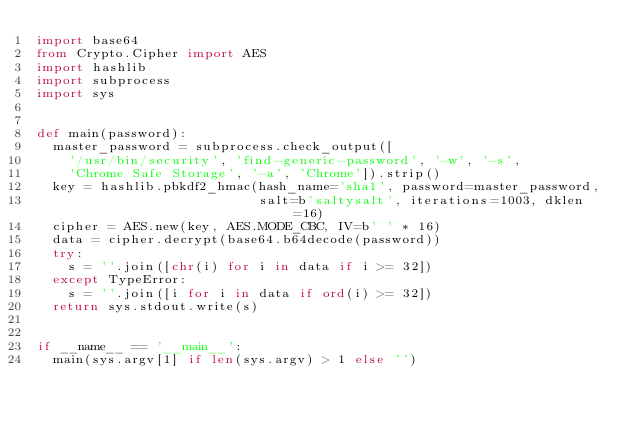Convert code to text. <code><loc_0><loc_0><loc_500><loc_500><_Python_>import base64
from Crypto.Cipher import AES
import hashlib
import subprocess
import sys


def main(password):
  master_password = subprocess.check_output([
    '/usr/bin/security', 'find-generic-password', '-w', '-s',
    'Chrome Safe Storage', '-a', 'Chrome']).strip()
  key = hashlib.pbkdf2_hmac(hash_name='sha1', password=master_password,
                            salt=b'saltysalt', iterations=1003, dklen=16)
  cipher = AES.new(key, AES.MODE_CBC, IV=b' ' * 16)
  data = cipher.decrypt(base64.b64decode(password))
  try:
    s = ''.join([chr(i) for i in data if i >= 32])
  except TypeError:
    s = ''.join([i for i in data if ord(i) >= 32])
  return sys.stdout.write(s)


if __name__ == '__main__':
  main(sys.argv[1] if len(sys.argv) > 1 else '')
</code> 